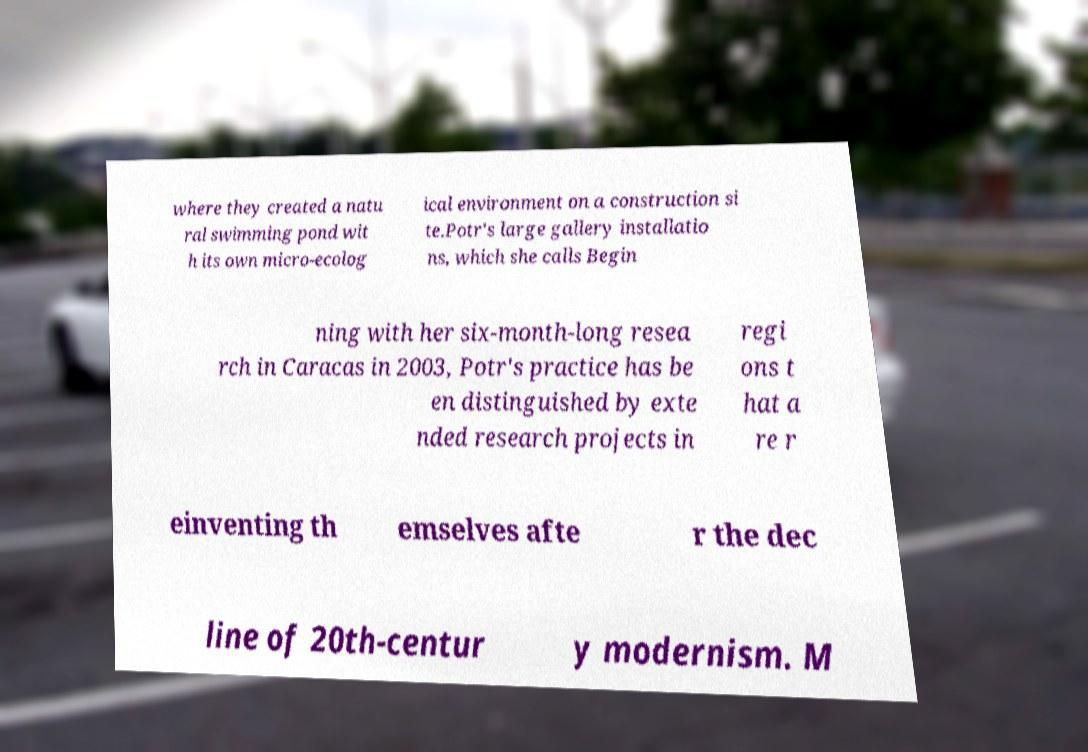Please identify and transcribe the text found in this image. where they created a natu ral swimming pond wit h its own micro-ecolog ical environment on a construction si te.Potr's large gallery installatio ns, which she calls Begin ning with her six-month-long resea rch in Caracas in 2003, Potr's practice has be en distinguished by exte nded research projects in regi ons t hat a re r einventing th emselves afte r the dec line of 20th-centur y modernism. M 